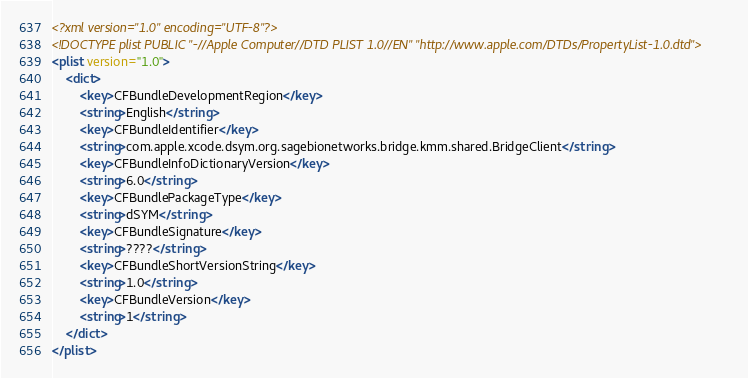<code> <loc_0><loc_0><loc_500><loc_500><_XML_><?xml version="1.0" encoding="UTF-8"?>
<!DOCTYPE plist PUBLIC "-//Apple Computer//DTD PLIST 1.0//EN" "http://www.apple.com/DTDs/PropertyList-1.0.dtd">
<plist version="1.0">
	<dict>
		<key>CFBundleDevelopmentRegion</key>
		<string>English</string>
		<key>CFBundleIdentifier</key>
		<string>com.apple.xcode.dsym.org.sagebionetworks.bridge.kmm.shared.BridgeClient</string>
		<key>CFBundleInfoDictionaryVersion</key>
		<string>6.0</string>
		<key>CFBundlePackageType</key>
		<string>dSYM</string>
		<key>CFBundleSignature</key>
		<string>????</string>
		<key>CFBundleShortVersionString</key>
		<string>1.0</string>
		<key>CFBundleVersion</key>
		<string>1</string>
	</dict>
</plist>
</code> 